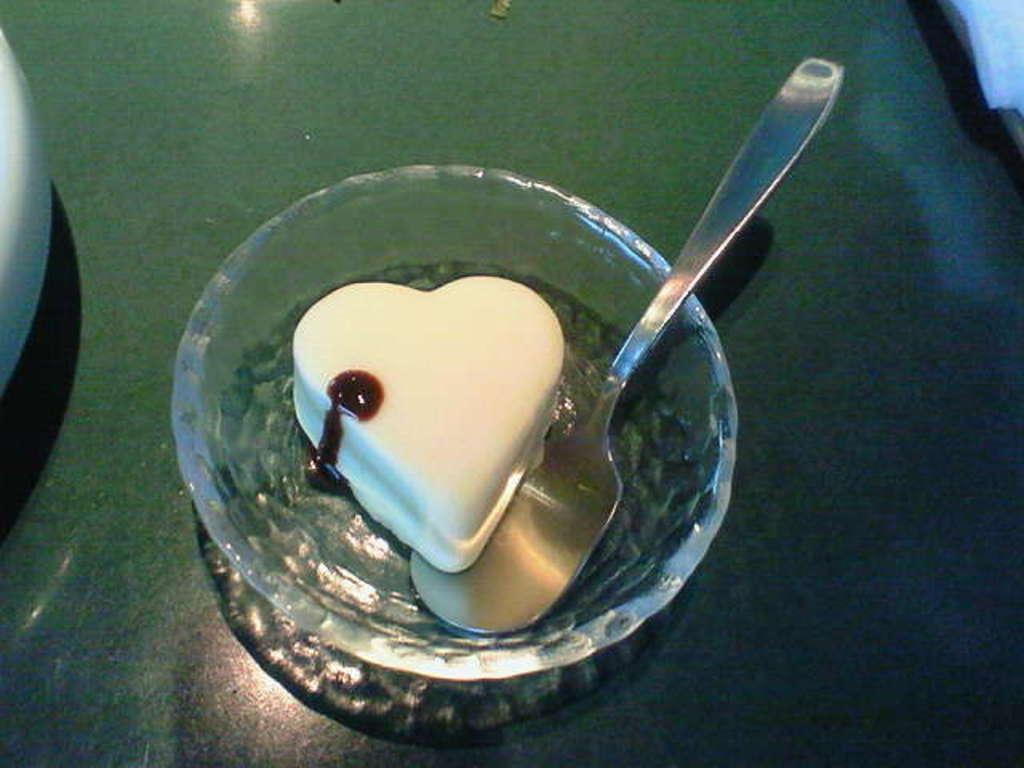What is in the bowl that is visible in the image? There is a bowl with food items in the image. What other objects can be seen on the green surface in the image? The provided facts do not specify any other objects on the green surface, so we cannot answer this question definitively. How many frogs are sitting on the suit in the image? There are no frogs or suits present in the image. What type of dress is visible on the green surface in the image? There is no dress present in the image. 